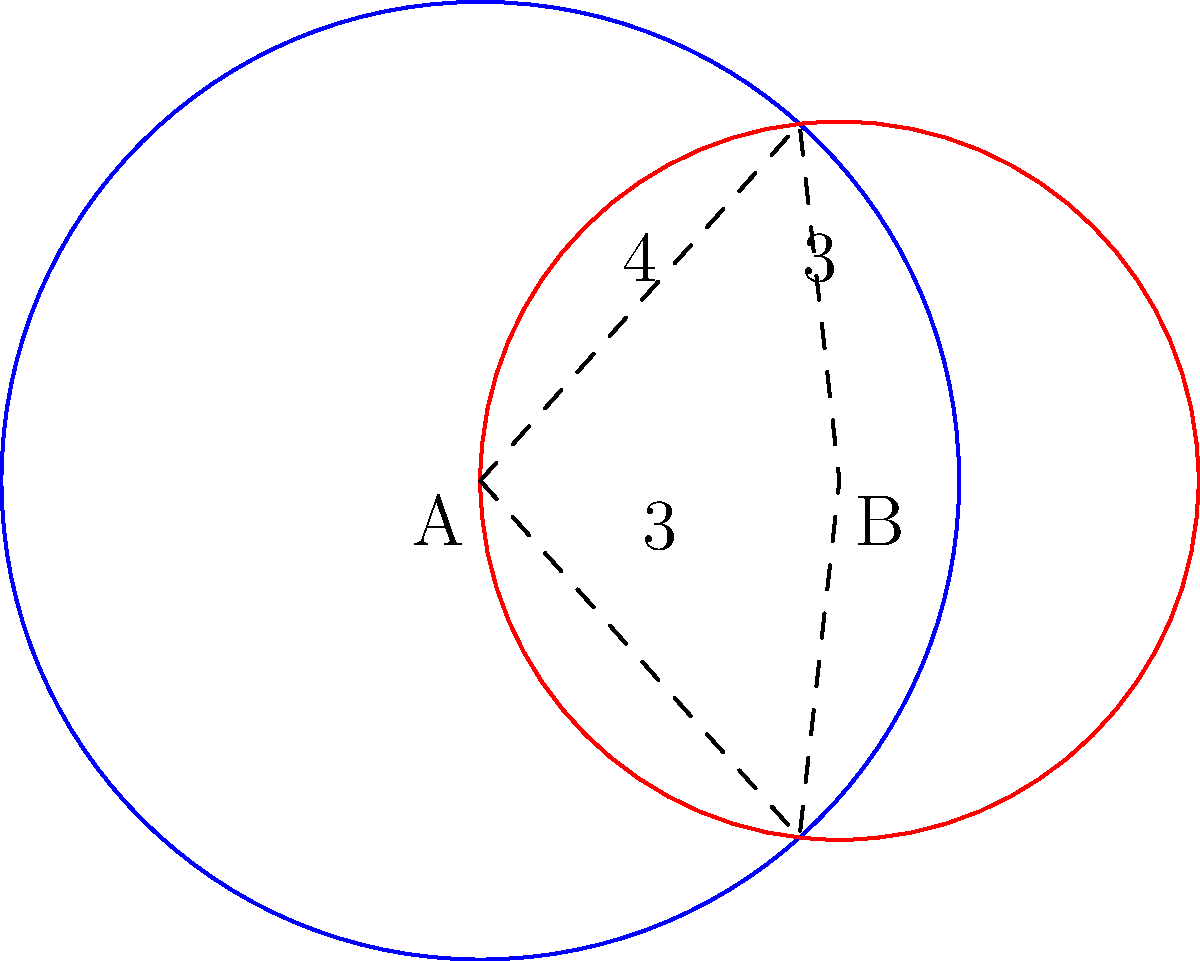Two circles represent our shared interests from school. Circle A has a radius of 4 units, and circle B has a radius of 3 units. The centers of the circles are 3 units apart. Calculate the area of the overlapping region (shaded area) that symbolizes our common interests. Round your answer to two decimal places. To find the area of overlap between two circles, we can use the following steps:

1) First, we need to find the angle $\theta$ (in radians) at the center of each circle formed by the line joining the centers and the line to an intersection point.

   For circle A: $\cos(\theta_A) = \frac{3^2 + 4^2 - 3^2}{2 \cdot 3 \cdot 4} = \frac{7}{8}$
   $\theta_A = \arccos(\frac{7}{8}) \approx 0.5055$ radians

   For circle B: $\cos(\theta_B) = \frac{3^2 + 3^2 - 4^2}{2 \cdot 3 \cdot 3} = \frac{1}{6}$
   $\theta_B = \arccos(\frac{1}{6}) \approx 1.5708$ radians

2) The area of a sector is given by $\frac{1}{2}r^2\theta$, where $r$ is the radius and $\theta$ is the angle in radians.

   Area of sector A = $\frac{1}{2} \cdot 4^2 \cdot 0.5055 \approx 4.0440$
   Area of sector B = $\frac{1}{2} \cdot 3^2 \cdot 1.5708 \approx 7.0686$

3) The area of the triangle formed by the centers and an intersection point:
   Area of triangle = $\frac{1}{2} \cdot 3 \cdot 4 \cdot \sin(0.5055) \approx 2.9781$

4) The area of overlap is the sum of the two sectors minus twice the area of the triangle:
   Overlap area = $(4.0440 + 7.0686) - 2(2.9781) = 11.1126 - 5.9562 = 5.1564$

5) Rounding to two decimal places: 5.16 square units.
Answer: 5.16 square units 